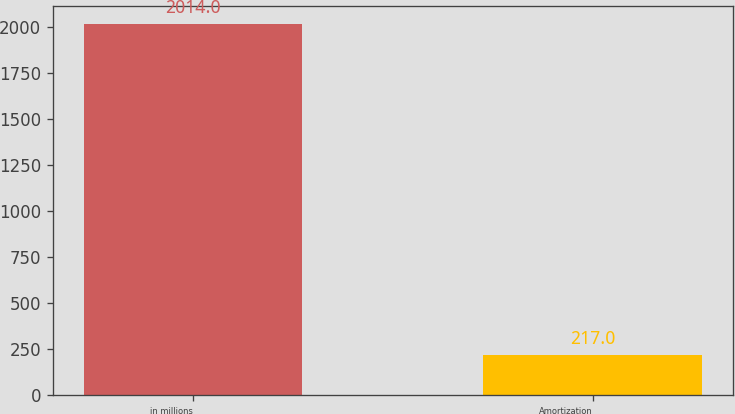<chart> <loc_0><loc_0><loc_500><loc_500><bar_chart><fcel>in millions<fcel>Amortization<nl><fcel>2014<fcel>217<nl></chart> 